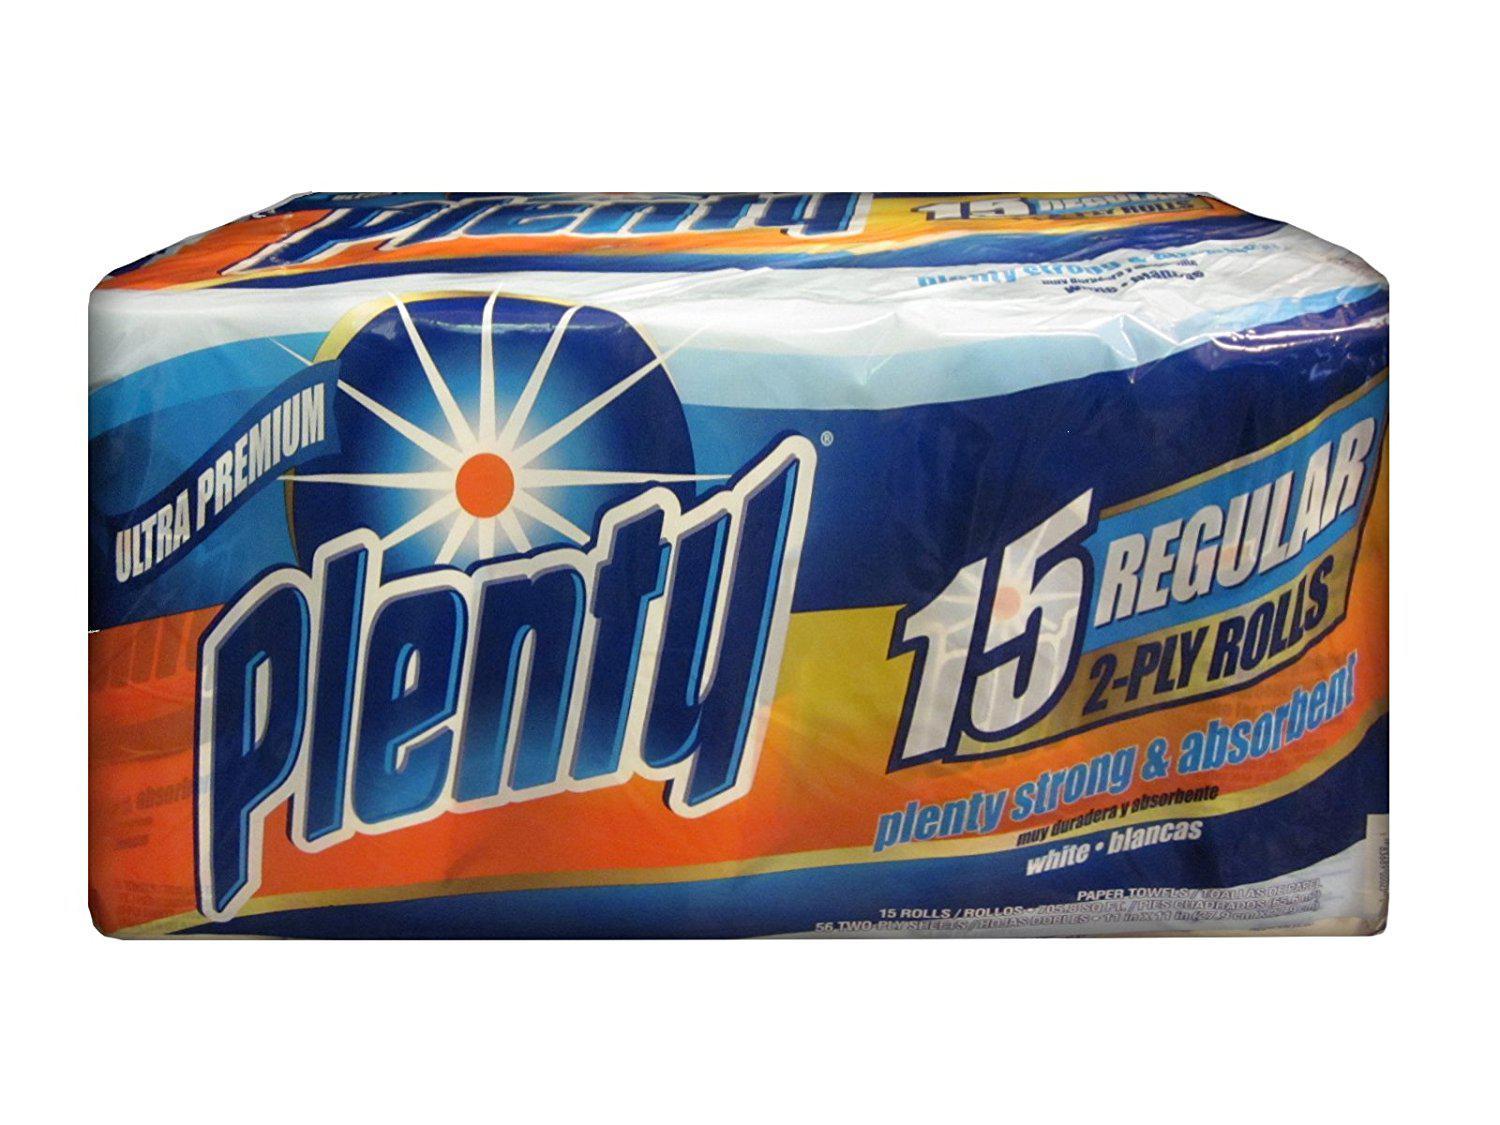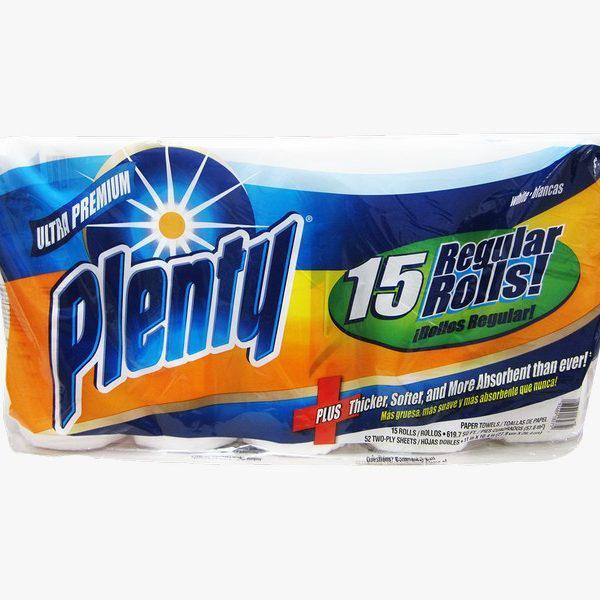The first image is the image on the left, the second image is the image on the right. Evaluate the accuracy of this statement regarding the images: "There are two packages of paper towels and one single paper towel roll.". Is it true? Answer yes or no. No. The first image is the image on the left, the second image is the image on the right. Considering the images on both sides, is "There are exactly 31 rolls of paper towels." valid? Answer yes or no. No. 